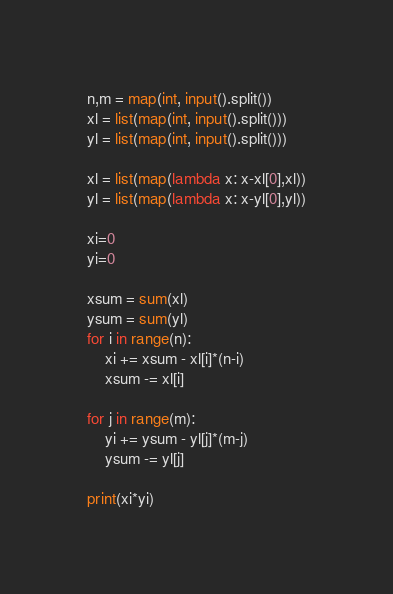<code> <loc_0><loc_0><loc_500><loc_500><_Python_>n,m = map(int, input().split())
xl = list(map(int, input().split())) 
yl = list(map(int, input().split())) 

xl = list(map(lambda x: x-xl[0],xl))
yl = list(map(lambda x: x-yl[0],yl))

xi=0
yi=0

xsum = sum(xl)
ysum = sum(yl)
for i in range(n):
    xi += xsum - xl[i]*(n-i)
    xsum -= xl[i] 
    
for j in range(m):
    yi += ysum - yl[j]*(m-j)
    ysum -= yl[j]

print(xi*yi)</code> 